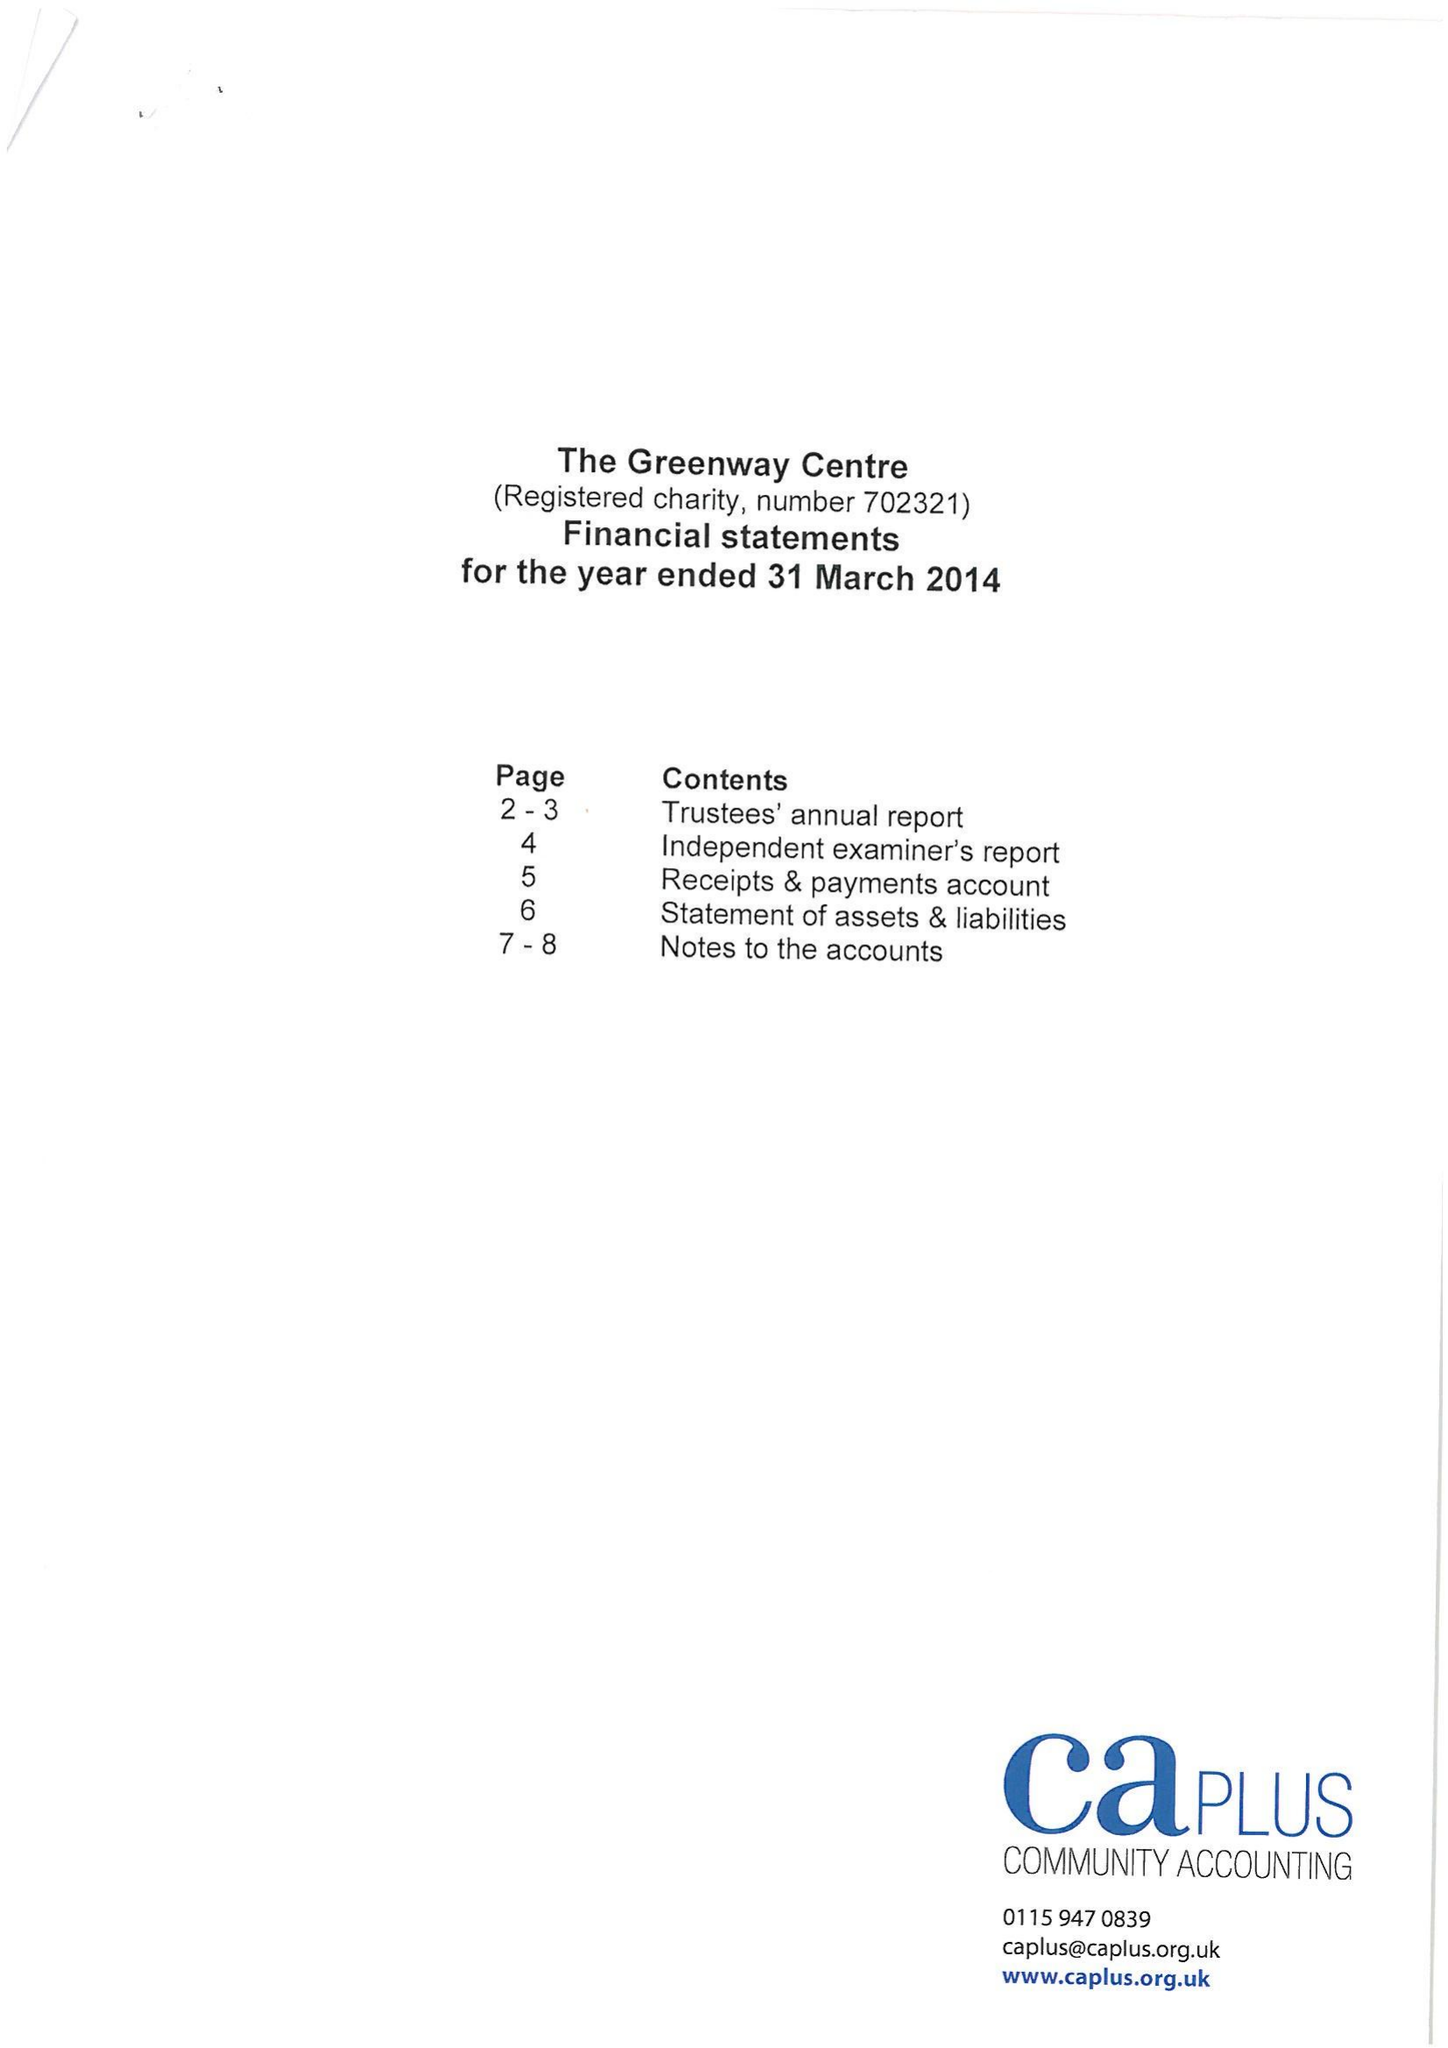What is the value for the address__street_line?
Answer the question using a single word or phrase. 38 ENA AVENUE 